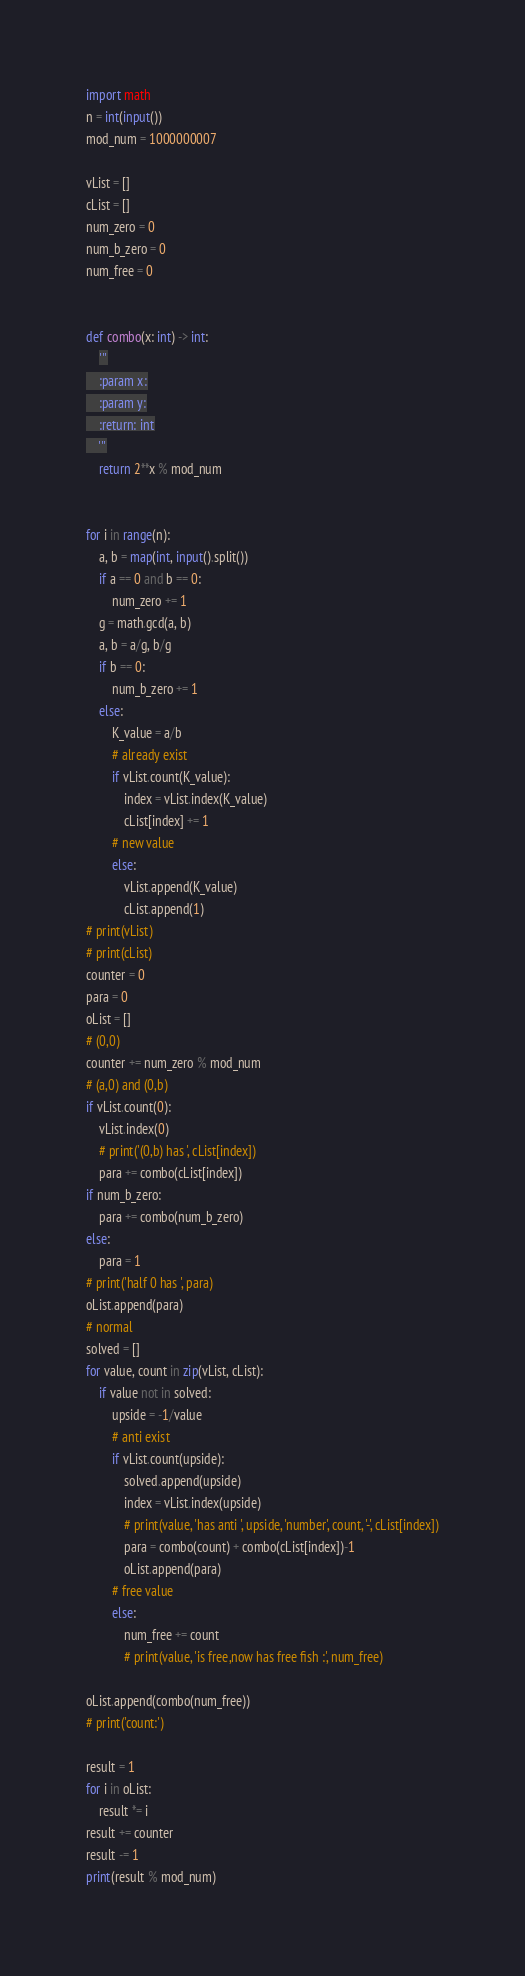Convert code to text. <code><loc_0><loc_0><loc_500><loc_500><_Python_>import math
n = int(input())
mod_num = 1000000007

vList = []
cList = []
num_zero = 0
num_b_zero = 0
num_free = 0


def combo(x: int) -> int:
    '''
    :param x:
    :param y:
    :return: int
    '''
    return 2**x % mod_num


for i in range(n):
    a, b = map(int, input().split())
    if a == 0 and b == 0:
        num_zero += 1
    g = math.gcd(a, b)
    a, b = a/g, b/g
    if b == 0:
        num_b_zero += 1
    else:
        K_value = a/b
        # already exist
        if vList.count(K_value):
            index = vList.index(K_value)
            cList[index] += 1
        # new value
        else:
            vList.append(K_value)
            cList.append(1)
# print(vList)
# print(cList)
counter = 0
para = 0
oList = []
# (0,0)
counter += num_zero % mod_num
# (a,0) and (0,b)
if vList.count(0):
    vList.index(0)
    # print('(0,b) has ', cList[index])
    para += combo(cList[index])
if num_b_zero:
    para += combo(num_b_zero)
else:
    para = 1
# print('half 0 has ', para)
oList.append(para)
# normal
solved = []
for value, count in zip(vList, cList):
    if value not in solved:
        upside = -1/value
        # anti exist
        if vList.count(upside):
            solved.append(upside)
            index = vList.index(upside)
            # print(value, 'has anti ', upside, 'number', count, '-', cList[index])
            para = combo(count) + combo(cList[index])-1
            oList.append(para)
        # free value
        else:
            num_free += count
            # print(value, 'is free,now has free fish :', num_free)

oList.append(combo(num_free))
# print('count:')

result = 1
for i in oList:
    result *= i
result += counter
result -= 1
print(result % mod_num)</code> 